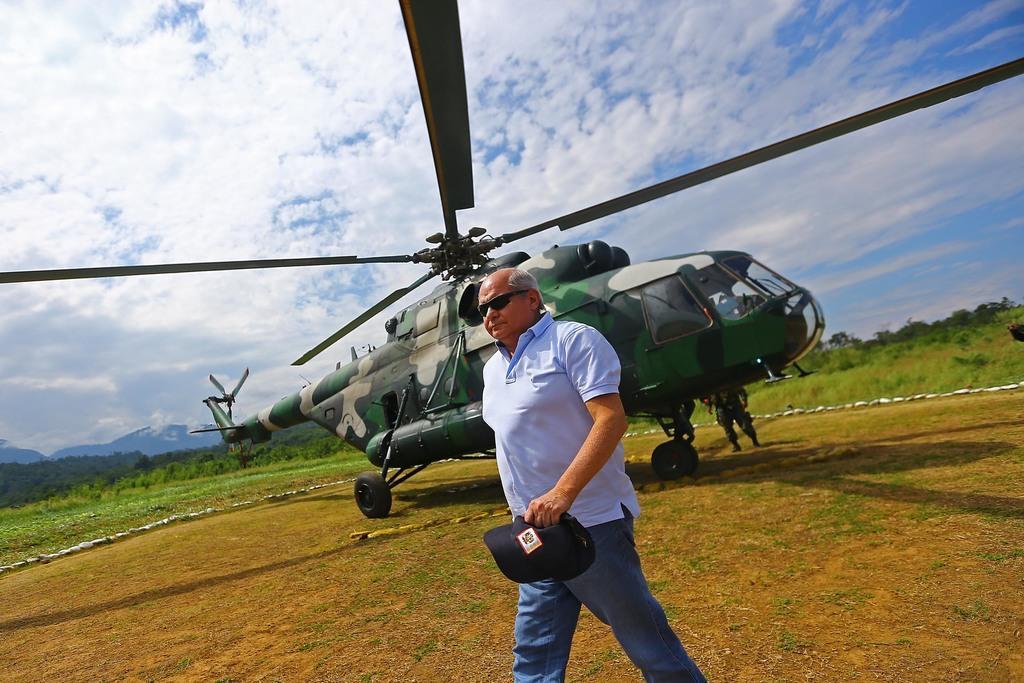How would you summarize this image in a sentence or two? In this image I can see an open ground and on it I can see a man and a camouflage colour helicopter. In the front I can see he is wearing t-shirt, jeans, black shades and I can see he is holding a cap. In the background I can see grass, number of trees, mountains, clouds and the sky. 